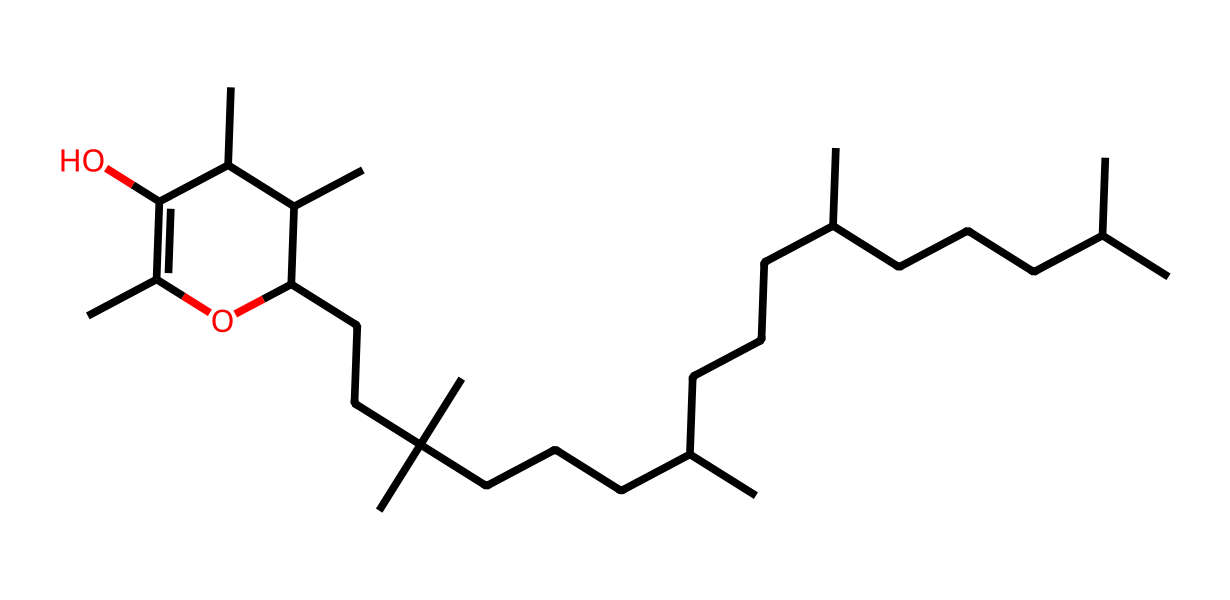What is the main functional group present in this chemical? The SMILES structure contains hydroxyl groups (-OH), which are indicative of alcohols. Thus, the presence of the -OH groups confirms this functional group.
Answer: hydroxyl group How many carbon atoms are present in this molecule? By analyzing the SMILES representation, each 'C' represents a carbon atom, and counting all carbon symbols gives a total of 27 carbon atoms in the structure.
Answer: 27 What role does Vitamin E play in coatings? Vitamin E acts as an antioxidant, preventing oxidative damage to paints and coatings, thus enhancing UV resistance and prolonging the life of the coatings.
Answer: antioxidant Is Vitamin E soluble in water or fat? Vitamin E is primarily a fat-soluble vitamin, which means it dissolves in fats and oils rather than in water.
Answer: fat What is the total number of hydroxyl (–OH) groups in this molecule? The SMILES representation includes two hydroxyl groups, indicated by the two occurrences of 'O' that are directly connected to carbon atoms in the structure.
Answer: 2 What is the significance of the branching in the carbon chain for Vitamin E's function? The branching in the carbon chain contributes to the hydrophobic characteristics of Vitamin E, which enhances its effectiveness as an antioxidant in lipid environments, providing stability against oxidation.
Answer: hydrophobic characteristics 